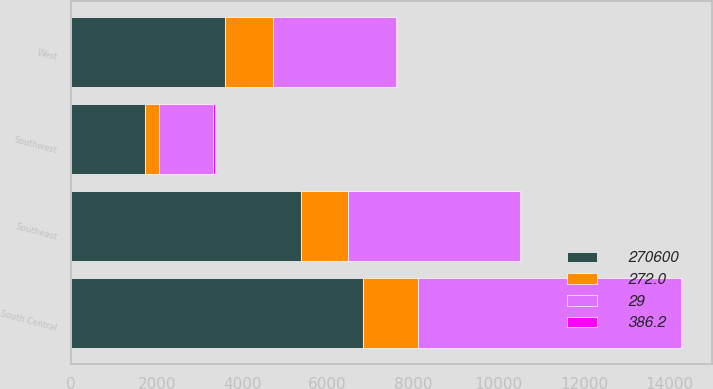Convert chart to OTSL. <chart><loc_0><loc_0><loc_500><loc_500><stacked_bar_chart><ecel><fcel>Southeast<fcel>South Central<fcel>Southwest<fcel>West<nl><fcel>270600<fcel>5378<fcel>6822<fcel>1715<fcel>3588<nl><fcel>29<fcel>4019<fcel>6169<fcel>1284<fcel>2878<nl><fcel>386.2<fcel>34<fcel>11<fcel>34<fcel>25<nl><fcel>272<fcel>1101.9<fcel>1282.3<fcel>327.7<fcel>1139.9<nl></chart> 